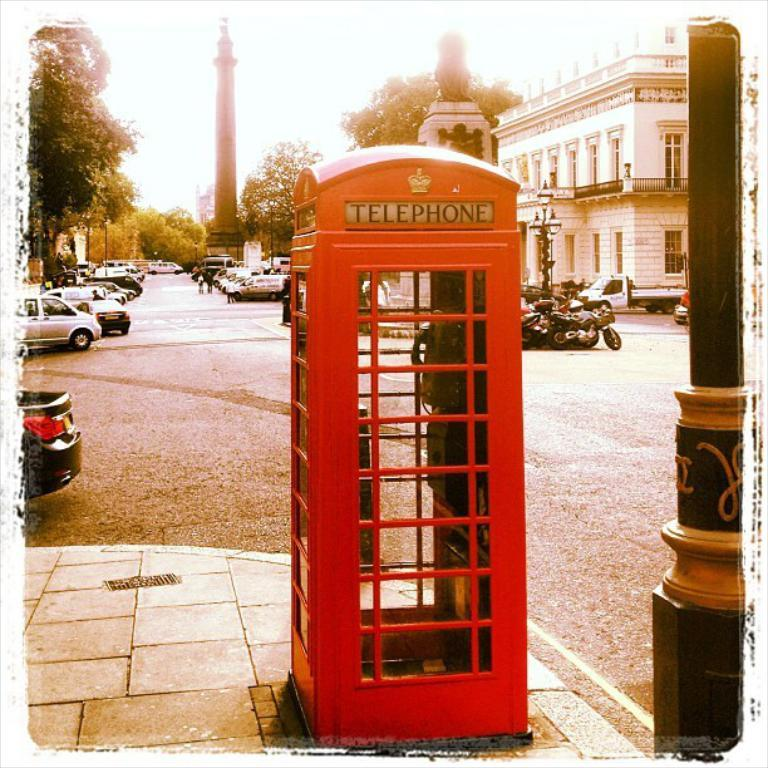<image>
Offer a succinct explanation of the picture presented. An old red phone booth with a sign TELEPHONE is on the street corner. 